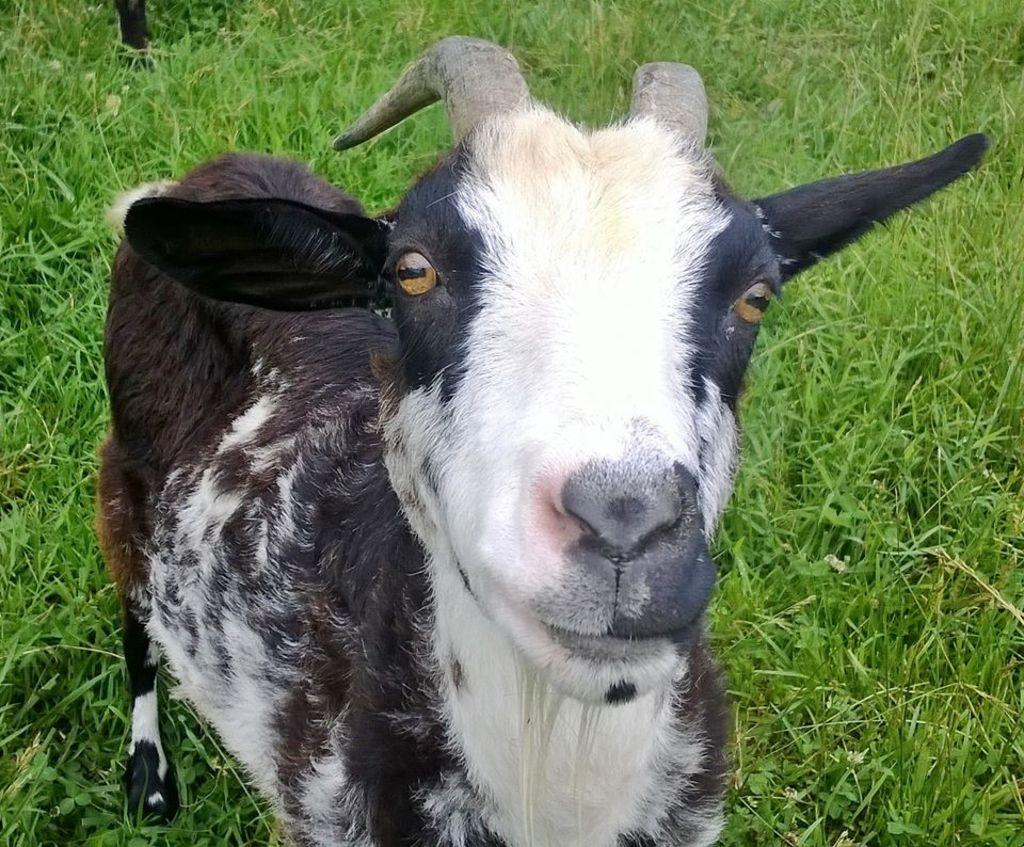What animal is present in the image? There is a goat in the image. What is the goat doing in the image? The goat is standing on the ground. What type of surface is the goat standing on? There is grass on the ground where the goat is standing. Where is the throne located in the image? There is no throne present in the image. What type of bucket can be seen in the image? There is no bucket present in the image. 